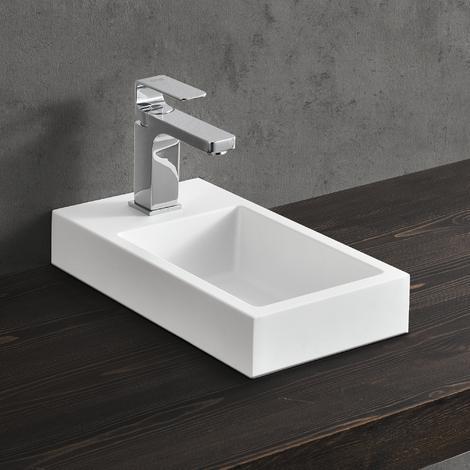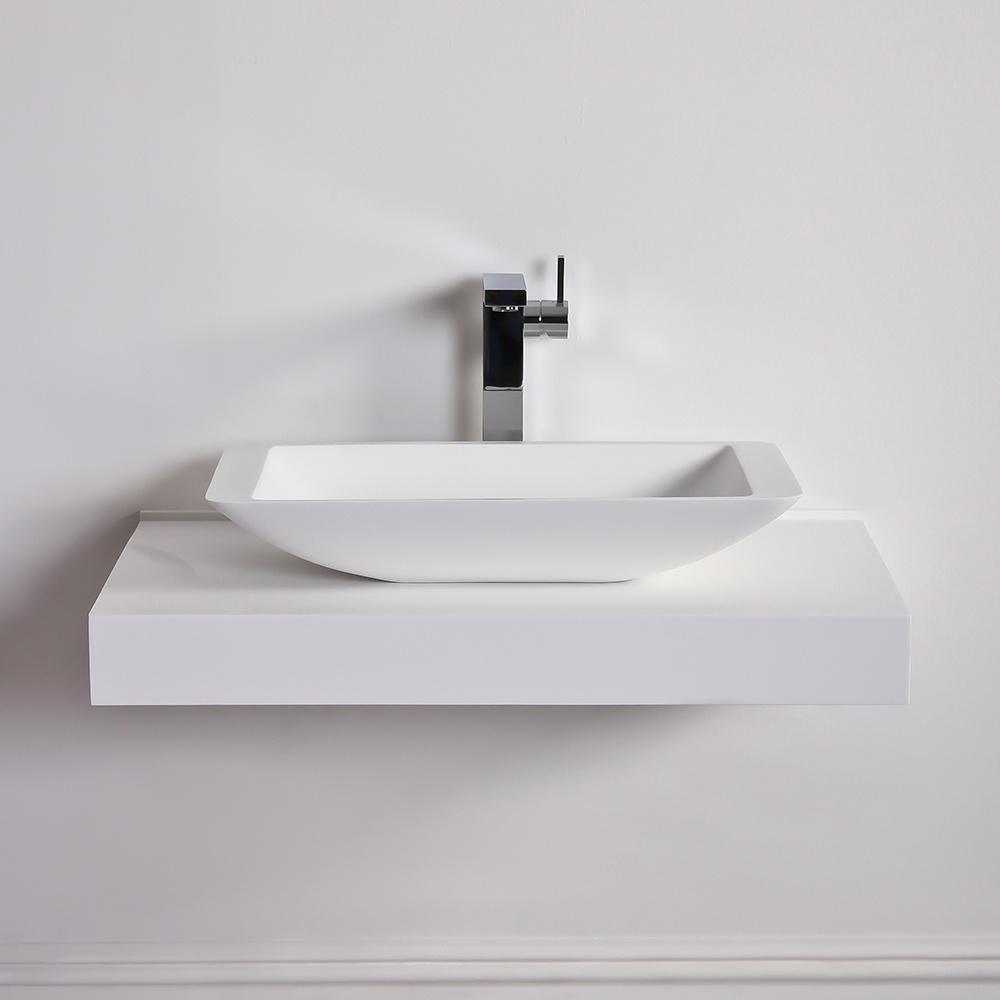The first image is the image on the left, the second image is the image on the right. Examine the images to the left and right. Is the description "The wall behind the sink is gray in one of the images." accurate? Answer yes or no. Yes. 